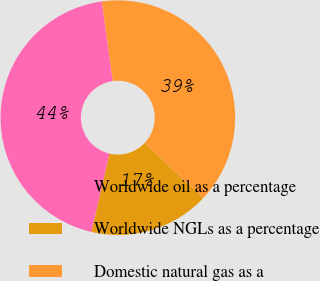Convert chart. <chart><loc_0><loc_0><loc_500><loc_500><pie_chart><fcel>Worldwide oil as a percentage<fcel>Worldwide NGLs as a percentage<fcel>Domestic natural gas as a<nl><fcel>44.22%<fcel>16.58%<fcel>39.2%<nl></chart> 